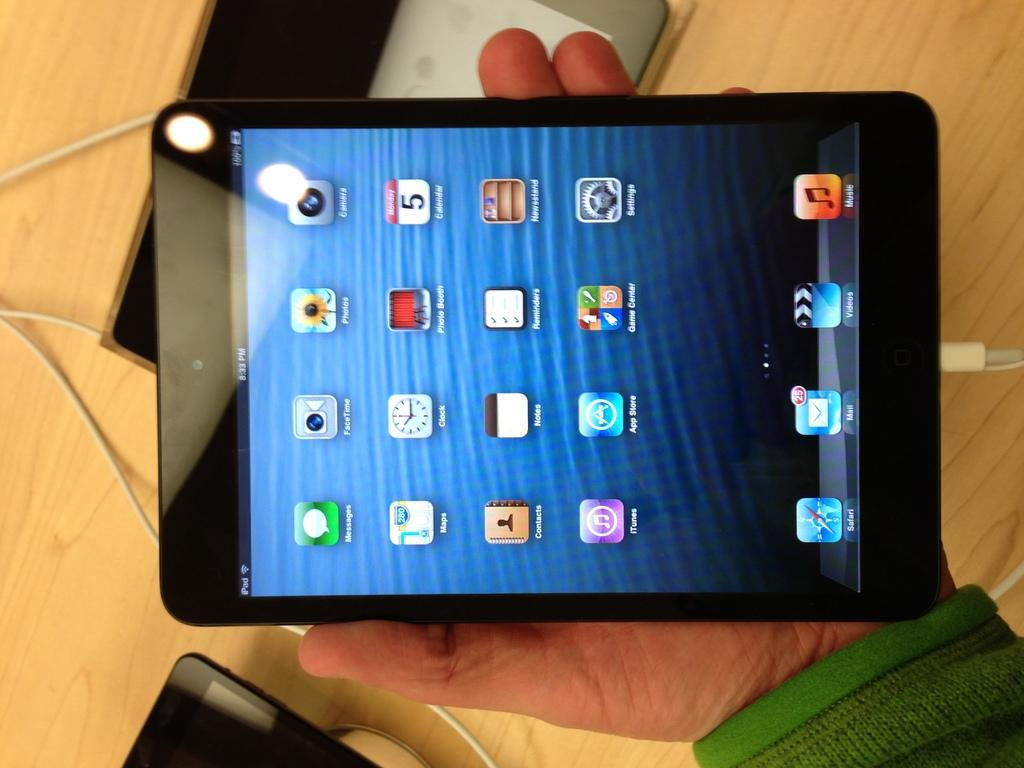What is the person holding in the image? There is a person's hand holding a tablet in the image. What is located at the bottom of the image? There is a table at the bottom of the image. What else can be seen in the image besides the person's hand and the tablet? Wires are visible in the image. What is placed on the table in the image? There are tablets placed on the table. What type of sign is displayed on the library wall in the image? There is no library or sign present in the image. 